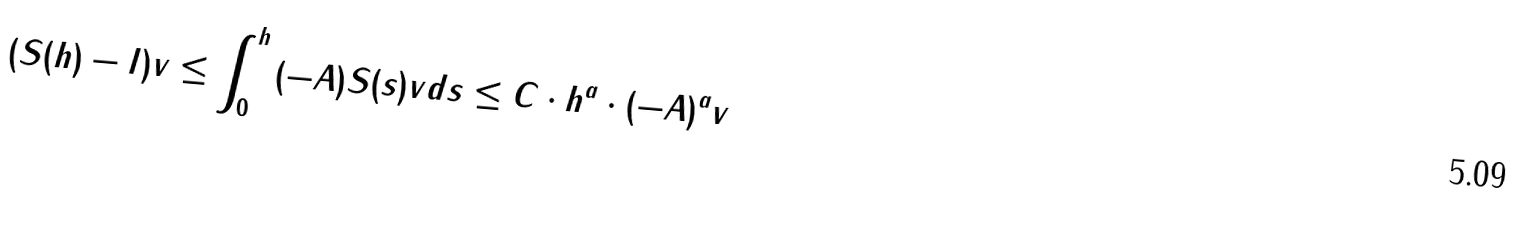Convert formula to latex. <formula><loc_0><loc_0><loc_500><loc_500>\| ( S ( h ) - I ) v \| \leq \int _ { 0 } ^ { h } \| ( - A ) S ( s ) v \| d s \leq C \cdot h ^ { a } \cdot \| ( - A ) ^ { a } v \|</formula> 